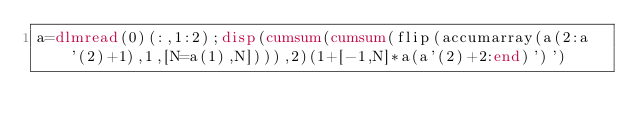<code> <loc_0><loc_0><loc_500><loc_500><_Octave_>a=dlmread(0)(:,1:2);disp(cumsum(cumsum(flip(accumarray(a(2:a'(2)+1),1,[N=a(1),N]))),2)(1+[-1,N]*a(a'(2)+2:end)')')</code> 